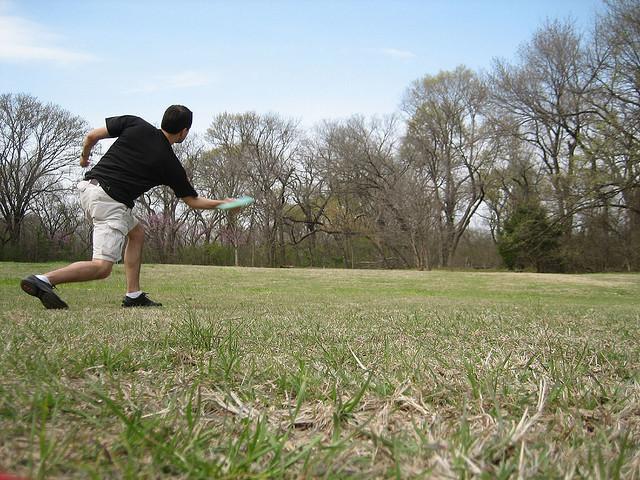How many people are in the photo?
Give a very brief answer. 1. 